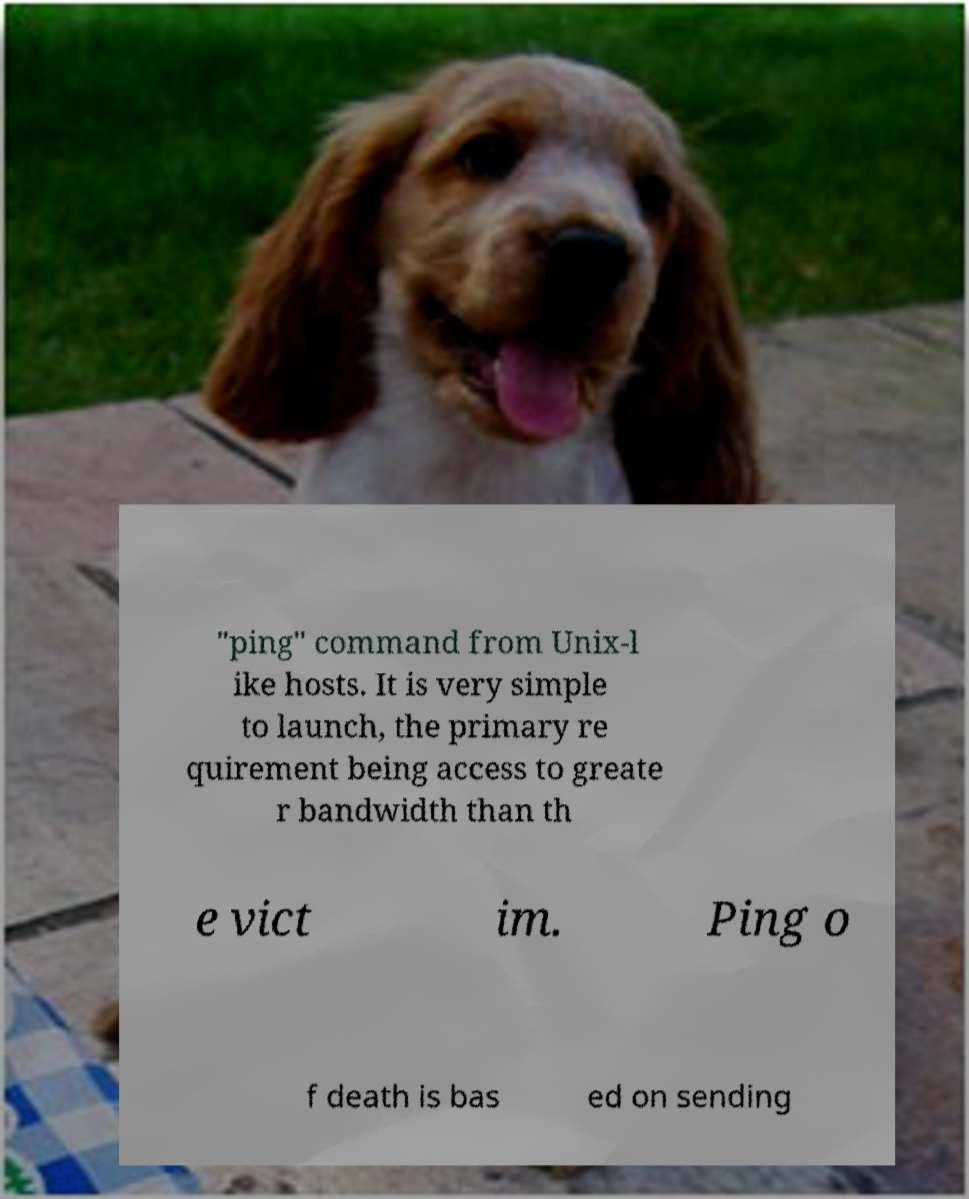For documentation purposes, I need the text within this image transcribed. Could you provide that? "ping" command from Unix-l ike hosts. It is very simple to launch, the primary re quirement being access to greate r bandwidth than th e vict im. Ping o f death is bas ed on sending 